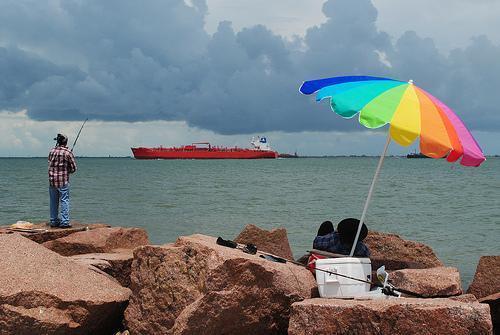How many people are in the photograph?
Give a very brief answer. 2. 